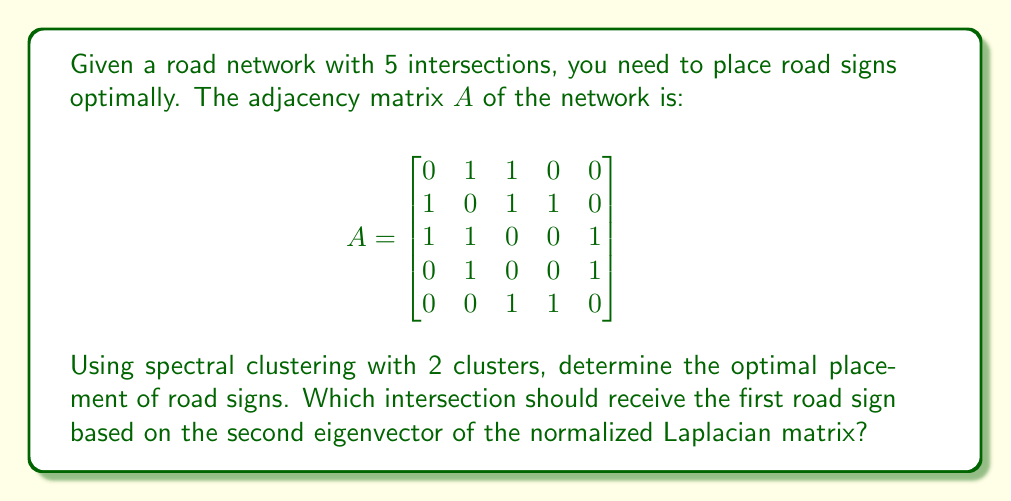What is the answer to this math problem? To solve this problem, we'll follow these steps:

1) Calculate the degree matrix $D$:
   $$D = \begin{bmatrix}
   2 & 0 & 0 & 0 & 0 \\
   0 & 3 & 0 & 0 & 0 \\
   0 & 0 & 3 & 0 & 0 \\
   0 & 0 & 0 & 2 & 0 \\
   0 & 0 & 0 & 0 & 2
   \end{bmatrix}$$

2) Calculate the normalized Laplacian matrix $L = I - D^{-1/2}AD^{-1/2}$:
   $$L = I - \begin{bmatrix}
   0 & \frac{1}{\sqrt{6}} & \frac{1}{\sqrt{6}} & 0 & 0 \\
   \frac{1}{\sqrt{6}} & 0 & \frac{1}{3} & \frac{1}{\sqrt{6}} & 0 \\
   \frac{1}{\sqrt{6}} & \frac{1}{3} & 0 & 0 & \frac{1}{\sqrt{6}} \\
   0 & \frac{1}{\sqrt{6}} & 0 & 0 & \frac{1}{\sqrt{4}} \\
   0 & 0 & \frac{1}{\sqrt{6}} & \frac{1}{\sqrt{4}} & 0
   \end{bmatrix}$$

3) Calculate the eigenvectors of $L$. The second eigenvector (corresponding to the second smallest eigenvalue) is approximately:
   $$v_2 \approx [-0.27, -0.65, 0.00, 0.54, 0.46]^T$$

4) The largest absolute value in $v_2$ corresponds to the optimal placement for the first road sign. This occurs at the second component.

5) Therefore, the optimal placement for the first road sign is at intersection 2.
Answer: Intersection 2 